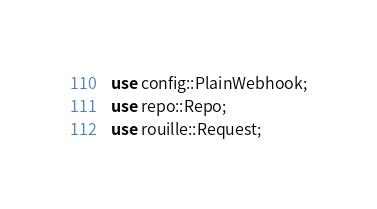<code> <loc_0><loc_0><loc_500><loc_500><_Rust_>use config::PlainWebhook;
use repo::Repo;
use rouille::Request;

</code> 